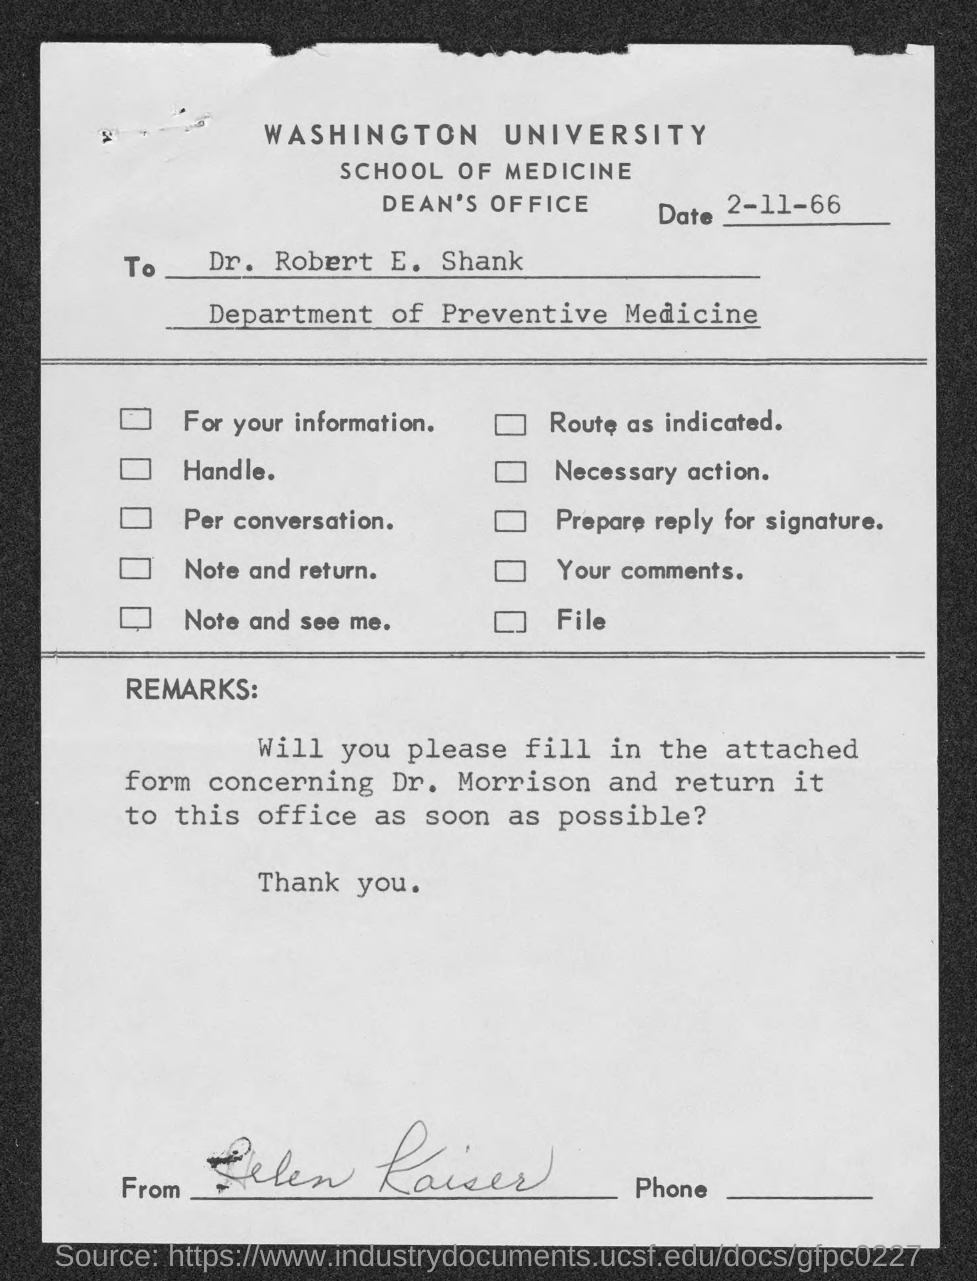Point out several critical features in this image. The top of the document reads, 'WASHINGTON UNIVERSITY.' The memorandum is dated on November 2, 1966. The memorandum is addressed to Dr. Robert E. Shank. 